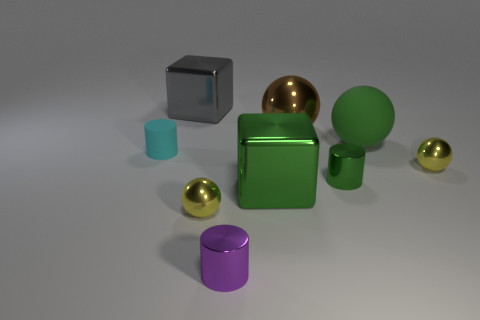What is the color of the other big cube that is made of the same material as the gray block?
Your answer should be compact. Green. How many big green cubes have the same material as the green ball?
Offer a very short reply. 0. What number of small yellow shiny spheres are there?
Offer a very short reply. 2. Do the small metal ball that is behind the green block and the large metal thing that is to the left of the purple thing have the same color?
Keep it short and to the point. No. How many green blocks are on the right side of the green metal cylinder?
Your answer should be compact. 0. There is a small cylinder that is the same color as the matte sphere; what is its material?
Your answer should be compact. Metal. Is there a green object of the same shape as the small purple metallic thing?
Keep it short and to the point. Yes. Is the material of the ball that is to the left of the brown object the same as the large cube that is behind the large brown sphere?
Your answer should be compact. Yes. There is a yellow sphere that is behind the tiny yellow metallic object in front of the small ball behind the tiny green cylinder; what is its size?
Ensure brevity in your answer.  Small. There is a block that is the same size as the gray thing; what is it made of?
Keep it short and to the point. Metal. 